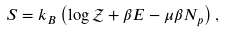Convert formula to latex. <formula><loc_0><loc_0><loc_500><loc_500>S = k _ { B } \left ( \log \mathcal { Z } + \beta E - \mu \beta N _ { p } \right ) ,</formula> 